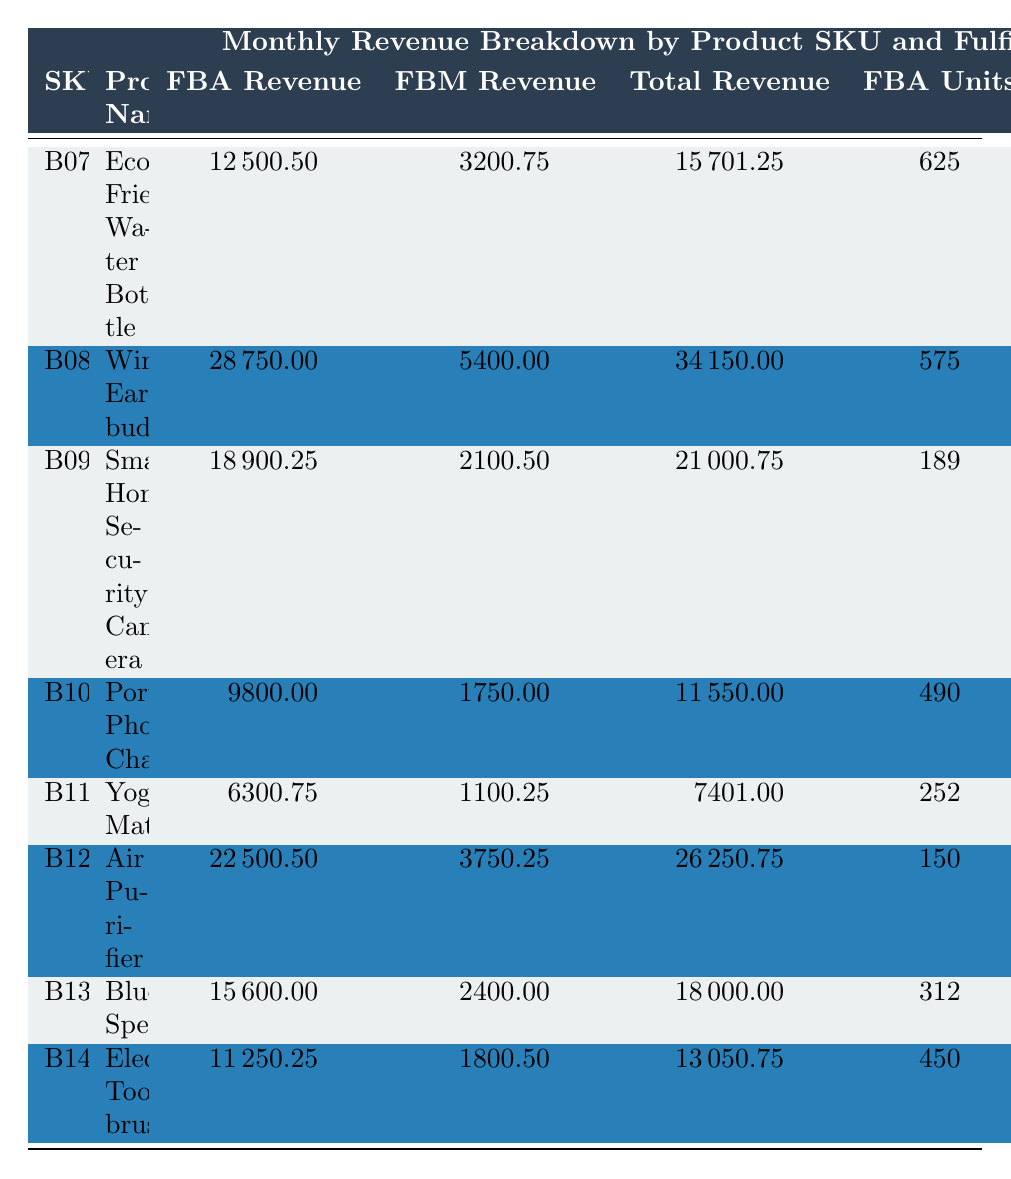What is the total revenue for the Yoga Mat? The total revenue for the Yoga Mat is listed in the table under 'Total Revenue' for SKU B11JKL7890, which shows a value of 7401.00.
Answer: 7401.00 Which product has the highest FBA revenue? To find this, we check the 'FBA Revenue' column and identify the maximum value, which is 28750.00 for the Wireless Earbuds (SKU B08ABC5678).
Answer: Wireless Earbuds How many total units were sold for the Smart Home Security Camera? The total units sold for the Smart Home Security Camera is provided directly in the 'Total Units Sold' column for SKU B09DEF9012, which is 210.
Answer: 210 Which SKU had the lowest FBM revenue? By comparing all values in the 'FBM Revenue' column, the lowest revenue is 1100.25 for the Yoga Mat (SKU B11JKL7890).
Answer: Yoga Mat What is the difference in total revenue between the Air Purifier and the Portable Phone Charger? The total revenue of the Air Purifier is 26250.75 and for the Portable Phone Charger, it is 11550.00. The difference is 26250.75 - 11550.00 = 14700.75.
Answer: 14700.75 What percentage of the total revenue comes from FBA for the Bluetooth Speaker? The total revenue is 18000.00, and FBA revenue is 15600.00. The percentage is calculated as (15600.00 / 18000.00) * 100 = 86.67%.
Answer: 86.67% Is it true that the total revenue from FBA is greater than the total revenue from FBM for every product? By examining the 'Total Revenue' vs 'FBM Revenue' for each product, FBA revenue exceeds FBM revenue in all cases, confirming the statement is true.
Answer: Yes What is the average FBA revenue across all products? The FBA revenue values are: 12500.50, 28750.00, 18900.25, 9800.00, 6300.75, 22500.50, 15600.00, 11250.25. The sum is 12500.50 + 28750.00 + 18900.25 + 9800.00 + 6300.75 + 22500.50 + 15600.00 + 11250.25 = 118,101.25. There are 8 products, so the average is 118101.25 / 8 = 14763.91.
Answer: 14763.91 What is the total number of units sold for all products combined? To find the total units sold, we sum the 'Total Units Sold' for each SKU: 785 + 683 + 210 + 577 + 296 + 175 + 360 + 522 = 3368.
Answer: 3368 Which product generated the most total revenue? The total revenue is compared across all products. The Wireless Earbuds (SKU B08ABC5678) has the highest total revenue at 34150.00.
Answer: Wireless Earbuds 